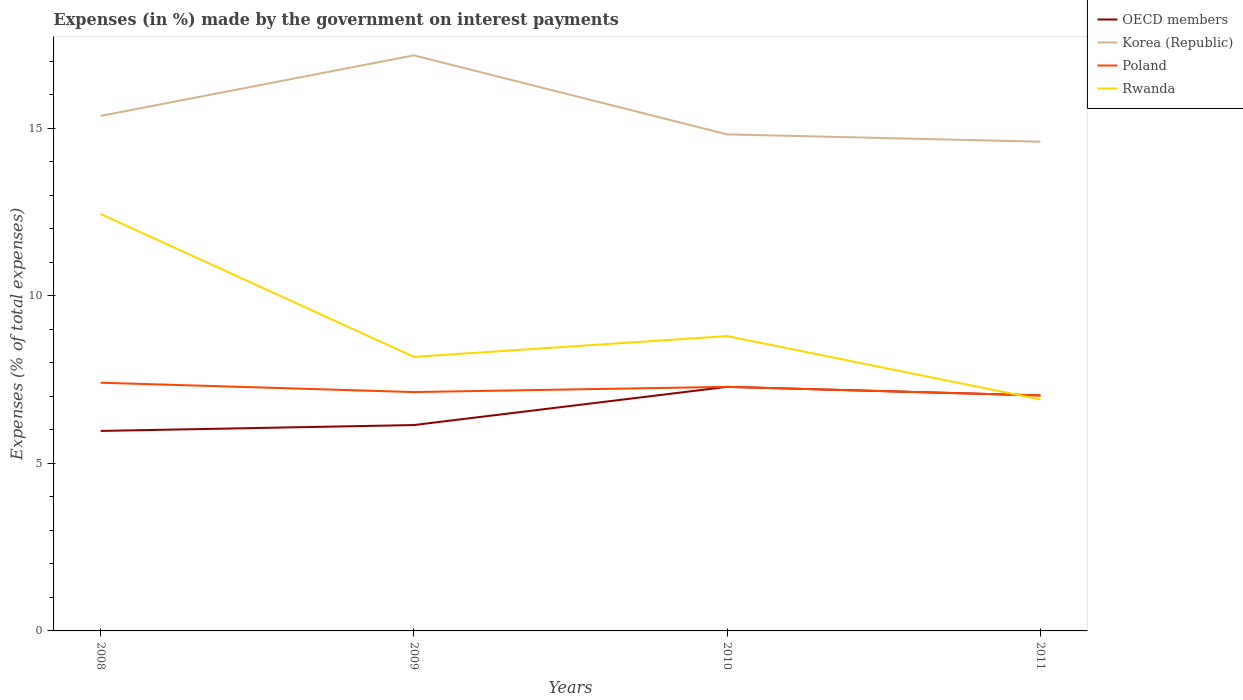How many different coloured lines are there?
Provide a short and direct response. 4. Does the line corresponding to OECD members intersect with the line corresponding to Rwanda?
Provide a short and direct response. Yes. Across all years, what is the maximum percentage of expenses made by the government on interest payments in OECD members?
Provide a succinct answer. 5.97. In which year was the percentage of expenses made by the government on interest payments in Poland maximum?
Ensure brevity in your answer.  2011. What is the total percentage of expenses made by the government on interest payments in Korea (Republic) in the graph?
Your answer should be compact. 0.77. What is the difference between the highest and the second highest percentage of expenses made by the government on interest payments in Poland?
Offer a terse response. 0.38. What is the difference between the highest and the lowest percentage of expenses made by the government on interest payments in Poland?
Provide a short and direct response. 2. How many lines are there?
Keep it short and to the point. 4. How many years are there in the graph?
Your answer should be compact. 4. What is the difference between two consecutive major ticks on the Y-axis?
Ensure brevity in your answer.  5. Does the graph contain grids?
Provide a succinct answer. No. Where does the legend appear in the graph?
Make the answer very short. Top right. What is the title of the graph?
Give a very brief answer. Expenses (in %) made by the government on interest payments. What is the label or title of the Y-axis?
Ensure brevity in your answer.  Expenses (% of total expenses). What is the Expenses (% of total expenses) of OECD members in 2008?
Give a very brief answer. 5.97. What is the Expenses (% of total expenses) in Korea (Republic) in 2008?
Provide a succinct answer. 15.36. What is the Expenses (% of total expenses) of Poland in 2008?
Your answer should be compact. 7.4. What is the Expenses (% of total expenses) in Rwanda in 2008?
Your answer should be compact. 12.44. What is the Expenses (% of total expenses) in OECD members in 2009?
Give a very brief answer. 6.14. What is the Expenses (% of total expenses) in Korea (Republic) in 2009?
Make the answer very short. 17.17. What is the Expenses (% of total expenses) of Poland in 2009?
Provide a succinct answer. 7.13. What is the Expenses (% of total expenses) of Rwanda in 2009?
Make the answer very short. 8.17. What is the Expenses (% of total expenses) of OECD members in 2010?
Offer a terse response. 7.28. What is the Expenses (% of total expenses) in Korea (Republic) in 2010?
Offer a very short reply. 14.81. What is the Expenses (% of total expenses) in Poland in 2010?
Your answer should be very brief. 7.28. What is the Expenses (% of total expenses) of Rwanda in 2010?
Ensure brevity in your answer.  8.8. What is the Expenses (% of total expenses) in OECD members in 2011?
Keep it short and to the point. 7.02. What is the Expenses (% of total expenses) in Korea (Republic) in 2011?
Ensure brevity in your answer.  14.59. What is the Expenses (% of total expenses) of Poland in 2011?
Provide a short and direct response. 7.02. What is the Expenses (% of total expenses) of Rwanda in 2011?
Your answer should be compact. 6.91. Across all years, what is the maximum Expenses (% of total expenses) in OECD members?
Provide a short and direct response. 7.28. Across all years, what is the maximum Expenses (% of total expenses) in Korea (Republic)?
Offer a very short reply. 17.17. Across all years, what is the maximum Expenses (% of total expenses) in Poland?
Your answer should be very brief. 7.4. Across all years, what is the maximum Expenses (% of total expenses) in Rwanda?
Offer a very short reply. 12.44. Across all years, what is the minimum Expenses (% of total expenses) of OECD members?
Provide a short and direct response. 5.97. Across all years, what is the minimum Expenses (% of total expenses) in Korea (Republic)?
Provide a short and direct response. 14.59. Across all years, what is the minimum Expenses (% of total expenses) of Poland?
Make the answer very short. 7.02. Across all years, what is the minimum Expenses (% of total expenses) in Rwanda?
Offer a very short reply. 6.91. What is the total Expenses (% of total expenses) in OECD members in the graph?
Offer a very short reply. 26.41. What is the total Expenses (% of total expenses) in Korea (Republic) in the graph?
Your response must be concise. 61.94. What is the total Expenses (% of total expenses) in Poland in the graph?
Your answer should be compact. 28.83. What is the total Expenses (% of total expenses) of Rwanda in the graph?
Your answer should be very brief. 36.31. What is the difference between the Expenses (% of total expenses) of OECD members in 2008 and that in 2009?
Offer a terse response. -0.18. What is the difference between the Expenses (% of total expenses) in Korea (Republic) in 2008 and that in 2009?
Offer a very short reply. -1.81. What is the difference between the Expenses (% of total expenses) of Poland in 2008 and that in 2009?
Provide a short and direct response. 0.28. What is the difference between the Expenses (% of total expenses) in Rwanda in 2008 and that in 2009?
Provide a short and direct response. 4.26. What is the difference between the Expenses (% of total expenses) in OECD members in 2008 and that in 2010?
Provide a short and direct response. -1.32. What is the difference between the Expenses (% of total expenses) of Korea (Republic) in 2008 and that in 2010?
Keep it short and to the point. 0.55. What is the difference between the Expenses (% of total expenses) in Poland in 2008 and that in 2010?
Your response must be concise. 0.12. What is the difference between the Expenses (% of total expenses) of Rwanda in 2008 and that in 2010?
Give a very brief answer. 3.64. What is the difference between the Expenses (% of total expenses) of OECD members in 2008 and that in 2011?
Give a very brief answer. -1.06. What is the difference between the Expenses (% of total expenses) in Korea (Republic) in 2008 and that in 2011?
Your response must be concise. 0.77. What is the difference between the Expenses (% of total expenses) in Poland in 2008 and that in 2011?
Make the answer very short. 0.38. What is the difference between the Expenses (% of total expenses) in Rwanda in 2008 and that in 2011?
Your response must be concise. 5.53. What is the difference between the Expenses (% of total expenses) of OECD members in 2009 and that in 2010?
Your answer should be compact. -1.14. What is the difference between the Expenses (% of total expenses) of Korea (Republic) in 2009 and that in 2010?
Offer a terse response. 2.36. What is the difference between the Expenses (% of total expenses) in Poland in 2009 and that in 2010?
Ensure brevity in your answer.  -0.16. What is the difference between the Expenses (% of total expenses) in Rwanda in 2009 and that in 2010?
Make the answer very short. -0.62. What is the difference between the Expenses (% of total expenses) in OECD members in 2009 and that in 2011?
Provide a short and direct response. -0.88. What is the difference between the Expenses (% of total expenses) in Korea (Republic) in 2009 and that in 2011?
Keep it short and to the point. 2.58. What is the difference between the Expenses (% of total expenses) in Poland in 2009 and that in 2011?
Ensure brevity in your answer.  0.1. What is the difference between the Expenses (% of total expenses) of Rwanda in 2009 and that in 2011?
Your answer should be compact. 1.27. What is the difference between the Expenses (% of total expenses) of OECD members in 2010 and that in 2011?
Your answer should be compact. 0.26. What is the difference between the Expenses (% of total expenses) of Korea (Republic) in 2010 and that in 2011?
Keep it short and to the point. 0.22. What is the difference between the Expenses (% of total expenses) of Poland in 2010 and that in 2011?
Ensure brevity in your answer.  0.26. What is the difference between the Expenses (% of total expenses) of Rwanda in 2010 and that in 2011?
Ensure brevity in your answer.  1.89. What is the difference between the Expenses (% of total expenses) of OECD members in 2008 and the Expenses (% of total expenses) of Korea (Republic) in 2009?
Ensure brevity in your answer.  -11.2. What is the difference between the Expenses (% of total expenses) of OECD members in 2008 and the Expenses (% of total expenses) of Poland in 2009?
Offer a terse response. -1.16. What is the difference between the Expenses (% of total expenses) of OECD members in 2008 and the Expenses (% of total expenses) of Rwanda in 2009?
Your answer should be very brief. -2.21. What is the difference between the Expenses (% of total expenses) of Korea (Republic) in 2008 and the Expenses (% of total expenses) of Poland in 2009?
Your answer should be very brief. 8.24. What is the difference between the Expenses (% of total expenses) in Korea (Republic) in 2008 and the Expenses (% of total expenses) in Rwanda in 2009?
Your answer should be very brief. 7.19. What is the difference between the Expenses (% of total expenses) in Poland in 2008 and the Expenses (% of total expenses) in Rwanda in 2009?
Your answer should be very brief. -0.77. What is the difference between the Expenses (% of total expenses) in OECD members in 2008 and the Expenses (% of total expenses) in Korea (Republic) in 2010?
Keep it short and to the point. -8.85. What is the difference between the Expenses (% of total expenses) in OECD members in 2008 and the Expenses (% of total expenses) in Poland in 2010?
Offer a terse response. -1.32. What is the difference between the Expenses (% of total expenses) in OECD members in 2008 and the Expenses (% of total expenses) in Rwanda in 2010?
Your answer should be compact. -2.83. What is the difference between the Expenses (% of total expenses) of Korea (Republic) in 2008 and the Expenses (% of total expenses) of Poland in 2010?
Provide a succinct answer. 8.08. What is the difference between the Expenses (% of total expenses) of Korea (Republic) in 2008 and the Expenses (% of total expenses) of Rwanda in 2010?
Offer a very short reply. 6.57. What is the difference between the Expenses (% of total expenses) in Poland in 2008 and the Expenses (% of total expenses) in Rwanda in 2010?
Offer a terse response. -1.39. What is the difference between the Expenses (% of total expenses) of OECD members in 2008 and the Expenses (% of total expenses) of Korea (Republic) in 2011?
Give a very brief answer. -8.63. What is the difference between the Expenses (% of total expenses) in OECD members in 2008 and the Expenses (% of total expenses) in Poland in 2011?
Provide a short and direct response. -1.06. What is the difference between the Expenses (% of total expenses) of OECD members in 2008 and the Expenses (% of total expenses) of Rwanda in 2011?
Your answer should be compact. -0.94. What is the difference between the Expenses (% of total expenses) of Korea (Republic) in 2008 and the Expenses (% of total expenses) of Poland in 2011?
Provide a short and direct response. 8.34. What is the difference between the Expenses (% of total expenses) in Korea (Republic) in 2008 and the Expenses (% of total expenses) in Rwanda in 2011?
Keep it short and to the point. 8.46. What is the difference between the Expenses (% of total expenses) in Poland in 2008 and the Expenses (% of total expenses) in Rwanda in 2011?
Make the answer very short. 0.5. What is the difference between the Expenses (% of total expenses) of OECD members in 2009 and the Expenses (% of total expenses) of Korea (Republic) in 2010?
Your answer should be compact. -8.67. What is the difference between the Expenses (% of total expenses) of OECD members in 2009 and the Expenses (% of total expenses) of Poland in 2010?
Your answer should be compact. -1.14. What is the difference between the Expenses (% of total expenses) in OECD members in 2009 and the Expenses (% of total expenses) in Rwanda in 2010?
Provide a short and direct response. -2.65. What is the difference between the Expenses (% of total expenses) of Korea (Republic) in 2009 and the Expenses (% of total expenses) of Poland in 2010?
Make the answer very short. 9.89. What is the difference between the Expenses (% of total expenses) of Korea (Republic) in 2009 and the Expenses (% of total expenses) of Rwanda in 2010?
Provide a short and direct response. 8.37. What is the difference between the Expenses (% of total expenses) of Poland in 2009 and the Expenses (% of total expenses) of Rwanda in 2010?
Your answer should be compact. -1.67. What is the difference between the Expenses (% of total expenses) of OECD members in 2009 and the Expenses (% of total expenses) of Korea (Republic) in 2011?
Provide a succinct answer. -8.45. What is the difference between the Expenses (% of total expenses) in OECD members in 2009 and the Expenses (% of total expenses) in Poland in 2011?
Make the answer very short. -0.88. What is the difference between the Expenses (% of total expenses) in OECD members in 2009 and the Expenses (% of total expenses) in Rwanda in 2011?
Keep it short and to the point. -0.76. What is the difference between the Expenses (% of total expenses) in Korea (Republic) in 2009 and the Expenses (% of total expenses) in Poland in 2011?
Offer a terse response. 10.15. What is the difference between the Expenses (% of total expenses) in Korea (Republic) in 2009 and the Expenses (% of total expenses) in Rwanda in 2011?
Your response must be concise. 10.26. What is the difference between the Expenses (% of total expenses) of Poland in 2009 and the Expenses (% of total expenses) of Rwanda in 2011?
Offer a terse response. 0.22. What is the difference between the Expenses (% of total expenses) in OECD members in 2010 and the Expenses (% of total expenses) in Korea (Republic) in 2011?
Ensure brevity in your answer.  -7.31. What is the difference between the Expenses (% of total expenses) of OECD members in 2010 and the Expenses (% of total expenses) of Poland in 2011?
Offer a very short reply. 0.26. What is the difference between the Expenses (% of total expenses) of OECD members in 2010 and the Expenses (% of total expenses) of Rwanda in 2011?
Provide a succinct answer. 0.38. What is the difference between the Expenses (% of total expenses) in Korea (Republic) in 2010 and the Expenses (% of total expenses) in Poland in 2011?
Your answer should be compact. 7.79. What is the difference between the Expenses (% of total expenses) of Korea (Republic) in 2010 and the Expenses (% of total expenses) of Rwanda in 2011?
Your response must be concise. 7.91. What is the difference between the Expenses (% of total expenses) in Poland in 2010 and the Expenses (% of total expenses) in Rwanda in 2011?
Ensure brevity in your answer.  0.38. What is the average Expenses (% of total expenses) in OECD members per year?
Make the answer very short. 6.6. What is the average Expenses (% of total expenses) in Korea (Republic) per year?
Offer a very short reply. 15.48. What is the average Expenses (% of total expenses) of Poland per year?
Keep it short and to the point. 7.21. What is the average Expenses (% of total expenses) of Rwanda per year?
Your answer should be very brief. 9.08. In the year 2008, what is the difference between the Expenses (% of total expenses) in OECD members and Expenses (% of total expenses) in Korea (Republic)?
Your answer should be compact. -9.4. In the year 2008, what is the difference between the Expenses (% of total expenses) in OECD members and Expenses (% of total expenses) in Poland?
Your answer should be very brief. -1.44. In the year 2008, what is the difference between the Expenses (% of total expenses) in OECD members and Expenses (% of total expenses) in Rwanda?
Keep it short and to the point. -6.47. In the year 2008, what is the difference between the Expenses (% of total expenses) in Korea (Republic) and Expenses (% of total expenses) in Poland?
Offer a terse response. 7.96. In the year 2008, what is the difference between the Expenses (% of total expenses) of Korea (Republic) and Expenses (% of total expenses) of Rwanda?
Keep it short and to the point. 2.93. In the year 2008, what is the difference between the Expenses (% of total expenses) of Poland and Expenses (% of total expenses) of Rwanda?
Ensure brevity in your answer.  -5.03. In the year 2009, what is the difference between the Expenses (% of total expenses) in OECD members and Expenses (% of total expenses) in Korea (Republic)?
Keep it short and to the point. -11.03. In the year 2009, what is the difference between the Expenses (% of total expenses) of OECD members and Expenses (% of total expenses) of Poland?
Ensure brevity in your answer.  -0.98. In the year 2009, what is the difference between the Expenses (% of total expenses) of OECD members and Expenses (% of total expenses) of Rwanda?
Offer a very short reply. -2.03. In the year 2009, what is the difference between the Expenses (% of total expenses) of Korea (Republic) and Expenses (% of total expenses) of Poland?
Your answer should be compact. 10.04. In the year 2009, what is the difference between the Expenses (% of total expenses) in Korea (Republic) and Expenses (% of total expenses) in Rwanda?
Provide a succinct answer. 8.99. In the year 2009, what is the difference between the Expenses (% of total expenses) in Poland and Expenses (% of total expenses) in Rwanda?
Keep it short and to the point. -1.05. In the year 2010, what is the difference between the Expenses (% of total expenses) of OECD members and Expenses (% of total expenses) of Korea (Republic)?
Ensure brevity in your answer.  -7.53. In the year 2010, what is the difference between the Expenses (% of total expenses) in OECD members and Expenses (% of total expenses) in Poland?
Provide a short and direct response. 0. In the year 2010, what is the difference between the Expenses (% of total expenses) of OECD members and Expenses (% of total expenses) of Rwanda?
Offer a very short reply. -1.51. In the year 2010, what is the difference between the Expenses (% of total expenses) of Korea (Republic) and Expenses (% of total expenses) of Poland?
Your response must be concise. 7.53. In the year 2010, what is the difference between the Expenses (% of total expenses) in Korea (Republic) and Expenses (% of total expenses) in Rwanda?
Give a very brief answer. 6.02. In the year 2010, what is the difference between the Expenses (% of total expenses) in Poland and Expenses (% of total expenses) in Rwanda?
Make the answer very short. -1.51. In the year 2011, what is the difference between the Expenses (% of total expenses) in OECD members and Expenses (% of total expenses) in Korea (Republic)?
Offer a very short reply. -7.57. In the year 2011, what is the difference between the Expenses (% of total expenses) of OECD members and Expenses (% of total expenses) of Poland?
Your answer should be compact. 0. In the year 2011, what is the difference between the Expenses (% of total expenses) in OECD members and Expenses (% of total expenses) in Rwanda?
Offer a terse response. 0.12. In the year 2011, what is the difference between the Expenses (% of total expenses) of Korea (Republic) and Expenses (% of total expenses) of Poland?
Keep it short and to the point. 7.57. In the year 2011, what is the difference between the Expenses (% of total expenses) of Korea (Republic) and Expenses (% of total expenses) of Rwanda?
Your response must be concise. 7.69. In the year 2011, what is the difference between the Expenses (% of total expenses) of Poland and Expenses (% of total expenses) of Rwanda?
Keep it short and to the point. 0.12. What is the ratio of the Expenses (% of total expenses) of OECD members in 2008 to that in 2009?
Provide a short and direct response. 0.97. What is the ratio of the Expenses (% of total expenses) in Korea (Republic) in 2008 to that in 2009?
Your answer should be very brief. 0.89. What is the ratio of the Expenses (% of total expenses) of Poland in 2008 to that in 2009?
Your response must be concise. 1.04. What is the ratio of the Expenses (% of total expenses) of Rwanda in 2008 to that in 2009?
Ensure brevity in your answer.  1.52. What is the ratio of the Expenses (% of total expenses) in OECD members in 2008 to that in 2010?
Your answer should be very brief. 0.82. What is the ratio of the Expenses (% of total expenses) in Korea (Republic) in 2008 to that in 2010?
Give a very brief answer. 1.04. What is the ratio of the Expenses (% of total expenses) in Poland in 2008 to that in 2010?
Offer a terse response. 1.02. What is the ratio of the Expenses (% of total expenses) of Rwanda in 2008 to that in 2010?
Your response must be concise. 1.41. What is the ratio of the Expenses (% of total expenses) in OECD members in 2008 to that in 2011?
Ensure brevity in your answer.  0.85. What is the ratio of the Expenses (% of total expenses) of Korea (Republic) in 2008 to that in 2011?
Provide a succinct answer. 1.05. What is the ratio of the Expenses (% of total expenses) of Poland in 2008 to that in 2011?
Provide a succinct answer. 1.05. What is the ratio of the Expenses (% of total expenses) of Rwanda in 2008 to that in 2011?
Your answer should be compact. 1.8. What is the ratio of the Expenses (% of total expenses) of OECD members in 2009 to that in 2010?
Give a very brief answer. 0.84. What is the ratio of the Expenses (% of total expenses) in Korea (Republic) in 2009 to that in 2010?
Offer a terse response. 1.16. What is the ratio of the Expenses (% of total expenses) of Poland in 2009 to that in 2010?
Provide a succinct answer. 0.98. What is the ratio of the Expenses (% of total expenses) of Rwanda in 2009 to that in 2010?
Your answer should be very brief. 0.93. What is the ratio of the Expenses (% of total expenses) of OECD members in 2009 to that in 2011?
Provide a short and direct response. 0.87. What is the ratio of the Expenses (% of total expenses) in Korea (Republic) in 2009 to that in 2011?
Offer a very short reply. 1.18. What is the ratio of the Expenses (% of total expenses) in Poland in 2009 to that in 2011?
Your response must be concise. 1.01. What is the ratio of the Expenses (% of total expenses) of Rwanda in 2009 to that in 2011?
Your answer should be very brief. 1.18. What is the ratio of the Expenses (% of total expenses) in OECD members in 2010 to that in 2011?
Provide a succinct answer. 1.04. What is the ratio of the Expenses (% of total expenses) in Korea (Republic) in 2010 to that in 2011?
Ensure brevity in your answer.  1.01. What is the ratio of the Expenses (% of total expenses) in Poland in 2010 to that in 2011?
Provide a succinct answer. 1.04. What is the ratio of the Expenses (% of total expenses) in Rwanda in 2010 to that in 2011?
Make the answer very short. 1.27. What is the difference between the highest and the second highest Expenses (% of total expenses) of OECD members?
Ensure brevity in your answer.  0.26. What is the difference between the highest and the second highest Expenses (% of total expenses) in Korea (Republic)?
Offer a very short reply. 1.81. What is the difference between the highest and the second highest Expenses (% of total expenses) in Poland?
Your answer should be very brief. 0.12. What is the difference between the highest and the second highest Expenses (% of total expenses) of Rwanda?
Offer a very short reply. 3.64. What is the difference between the highest and the lowest Expenses (% of total expenses) in OECD members?
Provide a succinct answer. 1.32. What is the difference between the highest and the lowest Expenses (% of total expenses) of Korea (Republic)?
Your answer should be very brief. 2.58. What is the difference between the highest and the lowest Expenses (% of total expenses) in Poland?
Your answer should be very brief. 0.38. What is the difference between the highest and the lowest Expenses (% of total expenses) in Rwanda?
Keep it short and to the point. 5.53. 